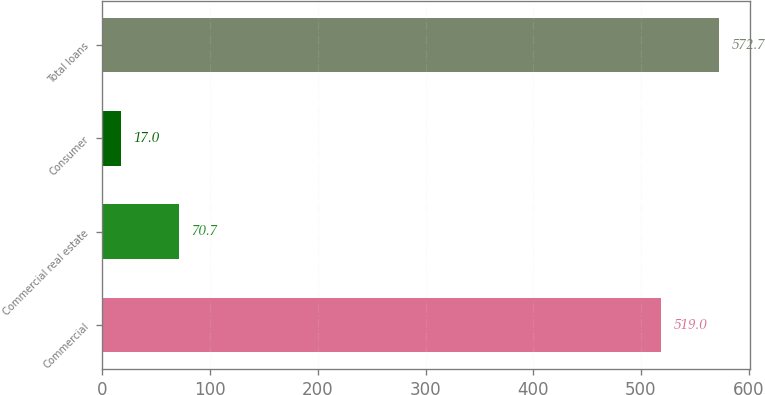Convert chart to OTSL. <chart><loc_0><loc_0><loc_500><loc_500><bar_chart><fcel>Commercial<fcel>Commercial real estate<fcel>Consumer<fcel>Total loans<nl><fcel>519<fcel>70.7<fcel>17<fcel>572.7<nl></chart> 